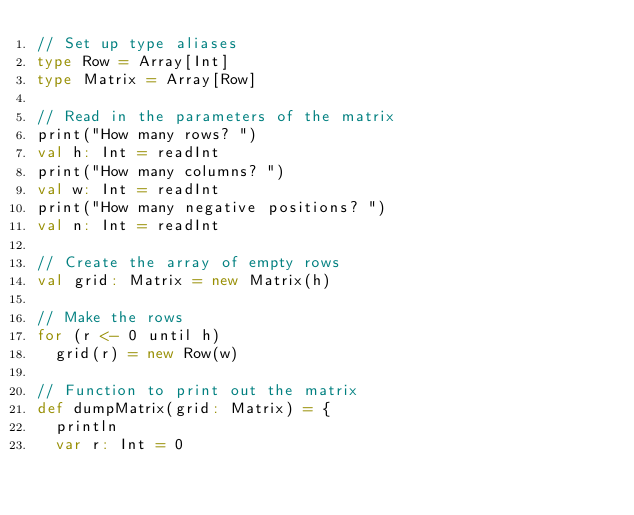<code> <loc_0><loc_0><loc_500><loc_500><_Scala_>// Set up type aliases
type Row = Array[Int]
type Matrix = Array[Row]

// Read in the parameters of the matrix
print("How many rows? ")
val h: Int = readInt
print("How many columns? ")
val w: Int = readInt
print("How many negative positions? ")
val n: Int = readInt

// Create the array of empty rows
val grid: Matrix = new Matrix(h)

// Make the rows
for (r <- 0 until h)
  grid(r) = new Row(w)

// Function to print out the matrix
def dumpMatrix(grid: Matrix) = {
  println
  var r: Int = 0</code> 